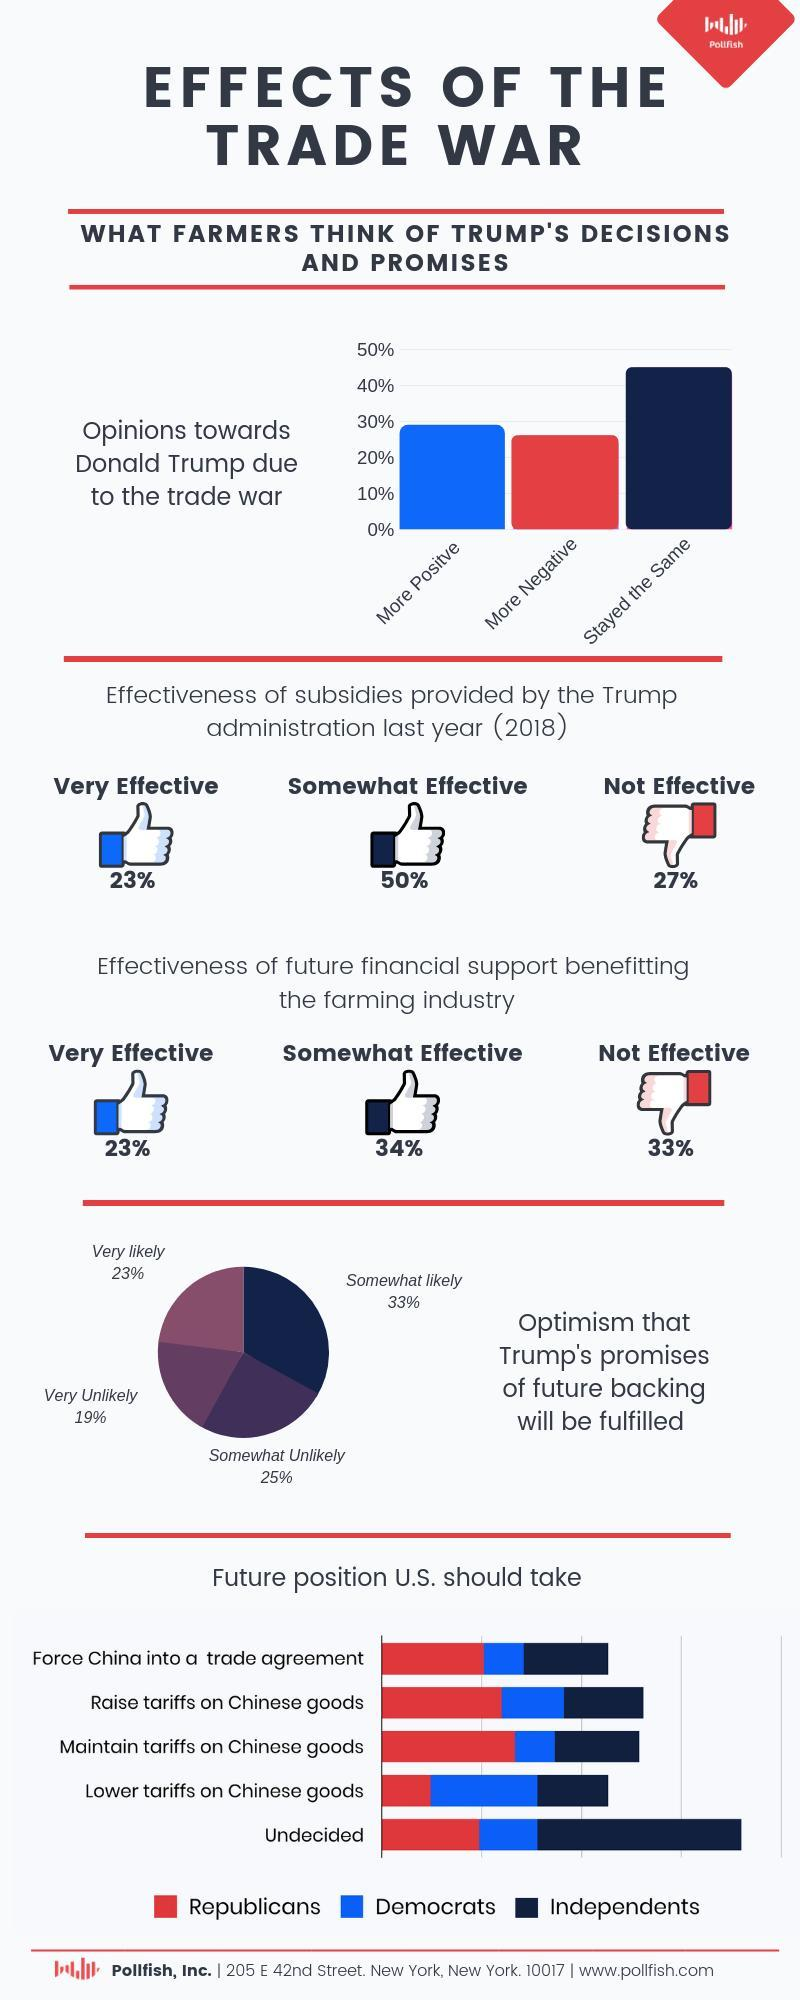what is the percentage of opinion that remain unchanged on policies of Trump?
Answer the question with a short phrase. 45 what percent of people responded positively on effectiveness  of subsidies provided by Trump last year? 73% what percent of people are hopeful that Trump's promises of future backing will be fulfilled? 56 what percent of people responded positively on effectiveness of future financial support? 57% what percent of people are hopeless on Trump's promises of future backing will be fulfilled? 44 